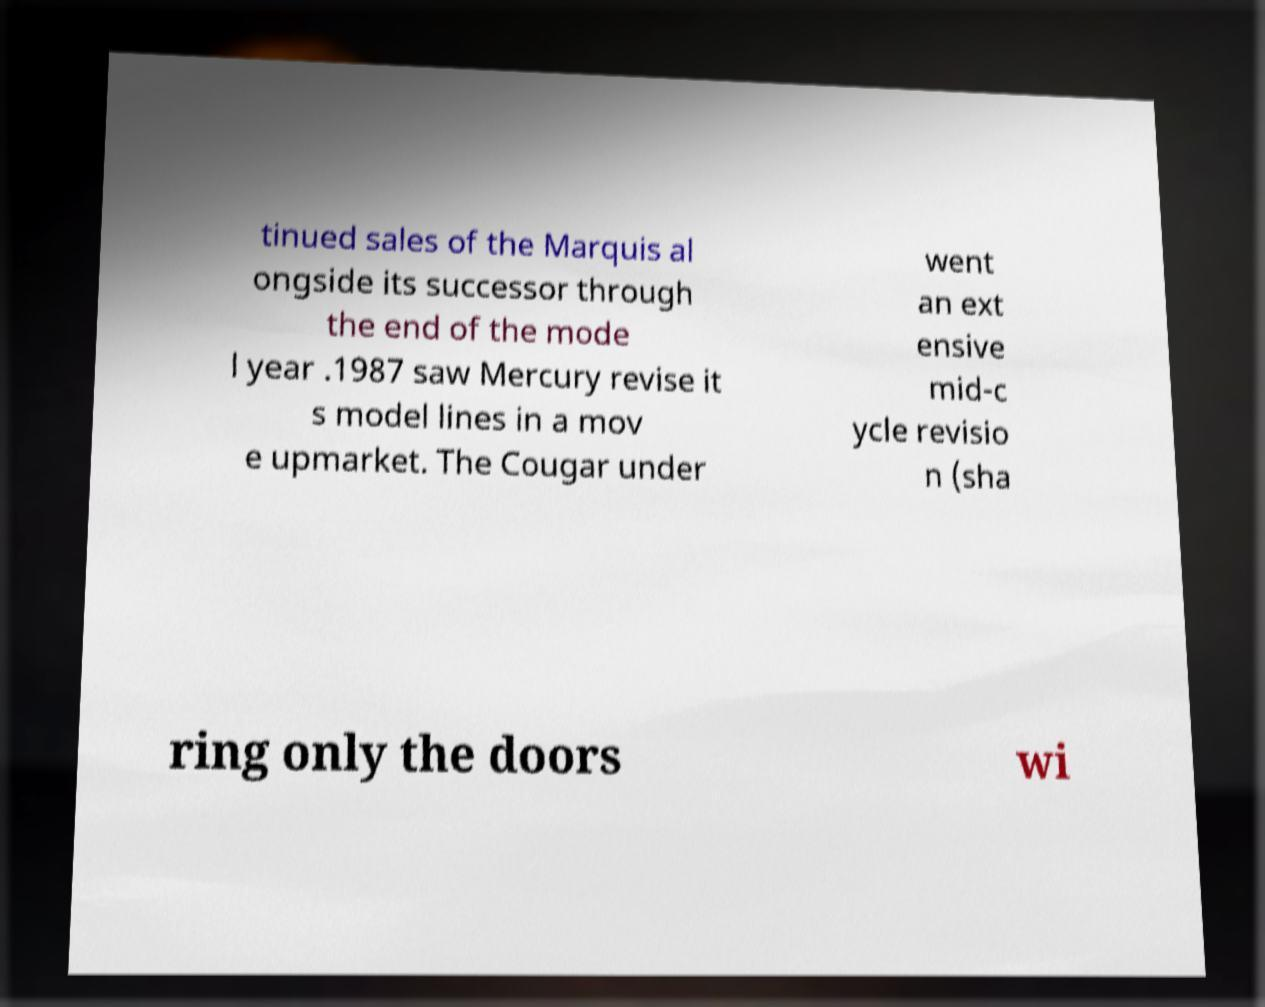For documentation purposes, I need the text within this image transcribed. Could you provide that? tinued sales of the Marquis al ongside its successor through the end of the mode l year .1987 saw Mercury revise it s model lines in a mov e upmarket. The Cougar under went an ext ensive mid-c ycle revisio n (sha ring only the doors wi 